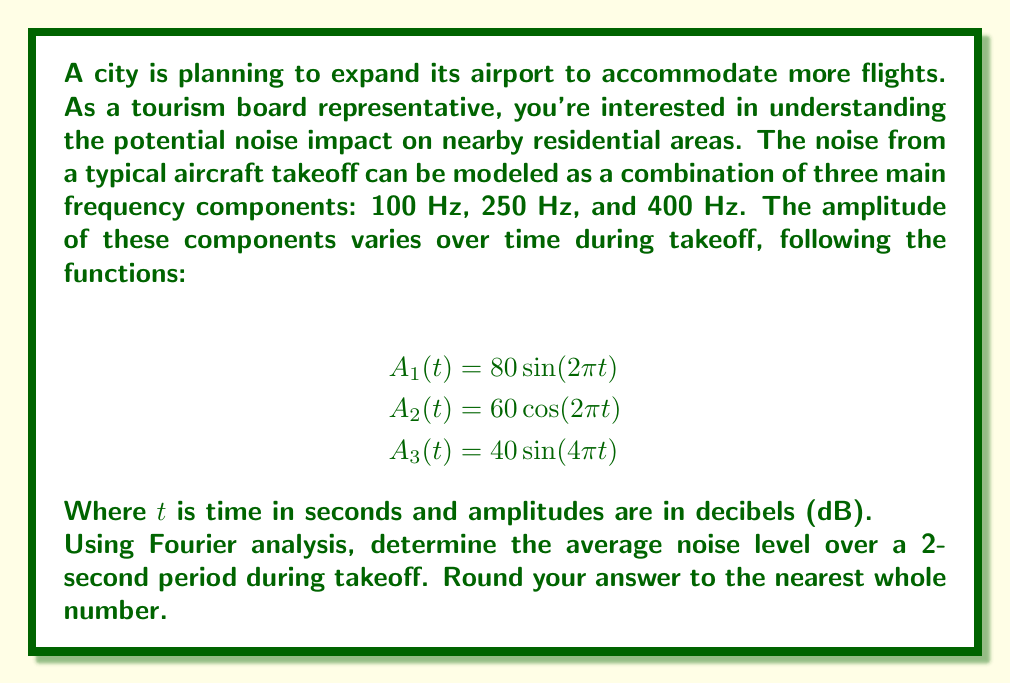What is the answer to this math problem? To solve this problem, we need to use Fourier analysis to combine the three frequency components and calculate the average noise level over time. Here's a step-by-step approach:

1) The total noise function $N(t)$ is the sum of the three components:

   $N(t) = 80 \sin(2\pi t) + 60 \cos(2\pi t) + 40 \sin(4\pi t)$

2) To find the average noise level, we need to calculate the root mean square (RMS) of this function over the 2-second period:

   $N_{RMS} = \sqrt{\frac{1}{T}\int_0^T N(t)^2 dt}$

   where $T = 2$ seconds.

3) Expand $N(t)^2$:

   $N(t)^2 = (80 \sin(2\pi t) + 60 \cos(2\pi t) + 40 \sin(4\pi t))^2$

4) Expand this further:

   $N(t)^2 = 6400 \sin^2(2\pi t) + 3600 \cos^2(2\pi t) + 1600 \sin^2(4\pi t)$
   $+ 9600 \sin(2\pi t)\cos(2\pi t) + 6400 \sin(2\pi t)\sin(4\pi t)$
   $+ 4800 \cos(2\pi t)\sin(4\pi t)$

5) Now, we need to integrate each term over the interval $[0,2]$:

   $\int_0^2 \sin^2(2\pi t) dt = \int_0^2 \cos^2(2\pi t) dt = 1$
   $\int_0^2 \sin^2(4\pi t) dt = 1$
   $\int_0^2 \sin(2\pi t)\cos(2\pi t) dt = 0$
   $\int_0^2 \sin(2\pi t)\sin(4\pi t) dt = 0$
   $\int_0^2 \cos(2\pi t)\sin(4\pi t) dt = 0$

6) Substituting these results:

   $\frac{1}{2}\int_0^2 N(t)^2 dt = \frac{1}{2}(6400 + 3600 + 1600) = 5800$

7) Taking the square root:

   $N_{RMS} = \sqrt{5800} \approx 76.16$ dB

8) Rounding to the nearest whole number:

   $N_{RMS} \approx 76$ dB
Answer: 76 dB 